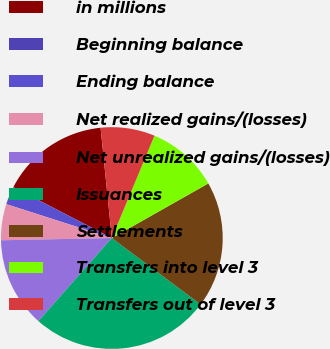Convert chart. <chart><loc_0><loc_0><loc_500><loc_500><pie_chart><fcel>in millions<fcel>Beginning balance<fcel>Ending balance<fcel>Net realized gains/(losses)<fcel>Net unrealized gains/(losses)<fcel>Issuances<fcel>Settlements<fcel>Transfers into level 3<fcel>Transfers out of level 3<nl><fcel>15.79%<fcel>0.01%<fcel>2.64%<fcel>5.27%<fcel>13.16%<fcel>26.3%<fcel>18.42%<fcel>10.53%<fcel>7.9%<nl></chart> 